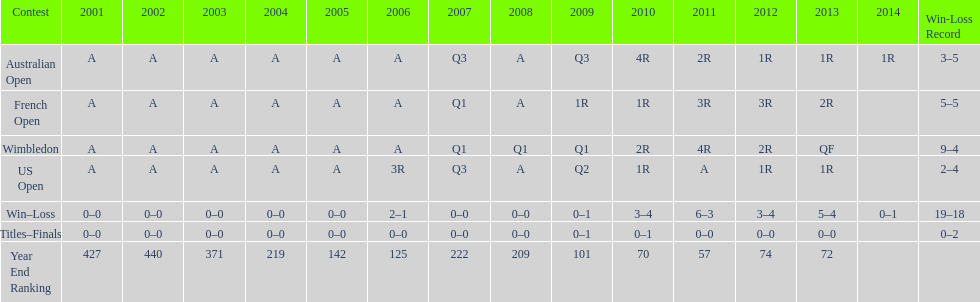What tournament has 5-5 as it's "w-l" record? French Open. 